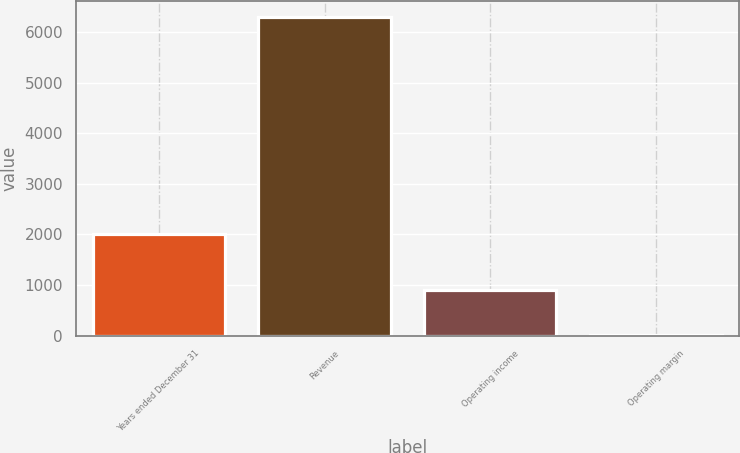Convert chart to OTSL. <chart><loc_0><loc_0><loc_500><loc_500><bar_chart><fcel>Years ended December 31<fcel>Revenue<fcel>Operating income<fcel>Operating margin<nl><fcel>2009<fcel>6305<fcel>900<fcel>14.3<nl></chart> 